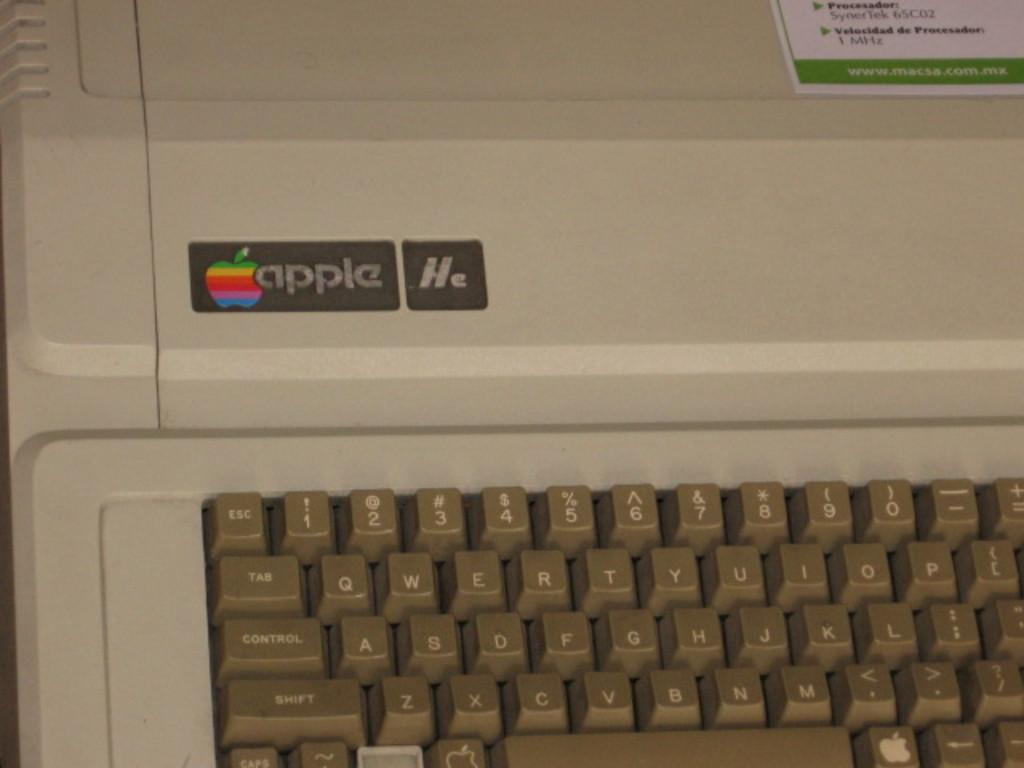What type of device is shown in the image? There is a keyboard in the image. What kind of keys are present on the keyboard? The keyboard has alphabets and numbers keys. Is there any text visible on the keyboard? Yes, the text "apple" is visible on the keyboard. Where is the sticker located on the keyboard? The sticker is on the top right side of the keyboard. What type of ant is crawling on the keyboard in the image? There are no ants present in the image; it only shows a keyboard with keys, text, and a sticker. 